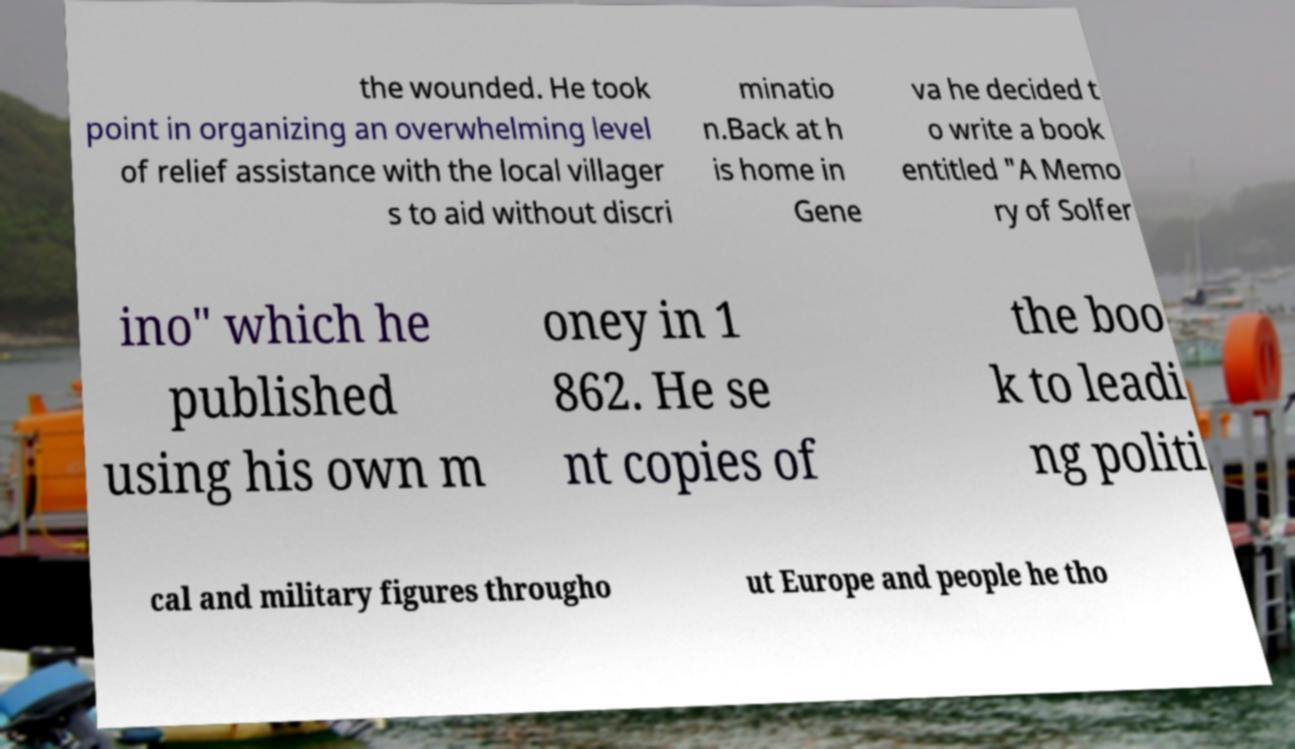Please read and relay the text visible in this image. What does it say? the wounded. He took point in organizing an overwhelming level of relief assistance with the local villager s to aid without discri minatio n.Back at h is home in Gene va he decided t o write a book entitled "A Memo ry of Solfer ino" which he published using his own m oney in 1 862. He se nt copies of the boo k to leadi ng politi cal and military figures througho ut Europe and people he tho 